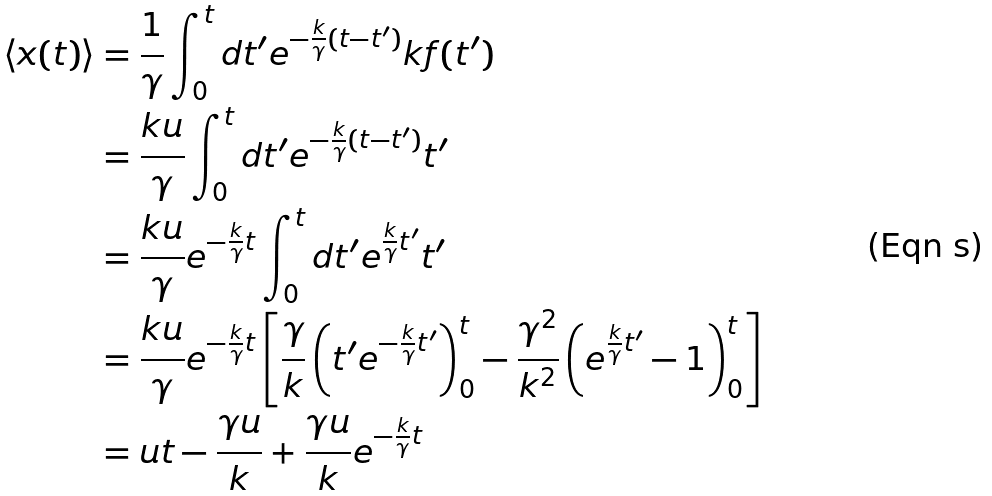<formula> <loc_0><loc_0><loc_500><loc_500>\left < x ( t ) \right > & = \frac { 1 } { \gamma } \int _ { 0 } ^ { t } d t ^ { \prime } e ^ { - \frac { k } { \gamma } ( t - t ^ { \prime } ) } k f ( t ^ { \prime } ) \\ & = \frac { k u } { \gamma } \int _ { 0 } ^ { t } d t ^ { \prime } e ^ { - \frac { k } { \gamma } ( t - t ^ { \prime } ) } t ^ { \prime } \\ & = \frac { k u } { \gamma } e ^ { - \frac { k } { \gamma } t } \int _ { 0 } ^ { t } d t ^ { \prime } e ^ { \frac { k } { \gamma } t ^ { \prime } } t ^ { \prime } \\ & = \frac { k u } { \gamma } e ^ { - \frac { k } { \gamma } t } \left [ \frac { \gamma } { k } \left ( t ^ { \prime } e ^ { - \frac { k } { \gamma } t ^ { \prime } } \right ) _ { 0 } ^ { t } - \frac { \gamma ^ { 2 } } { k ^ { 2 } } \left ( e ^ { \frac { k } { \gamma } t ^ { \prime } } - 1 \right ) _ { 0 } ^ { t } \right ] \\ & = u t - \frac { \gamma u } { k } + \frac { \gamma u } { k } e ^ { - \frac { k } { \gamma } t }</formula> 